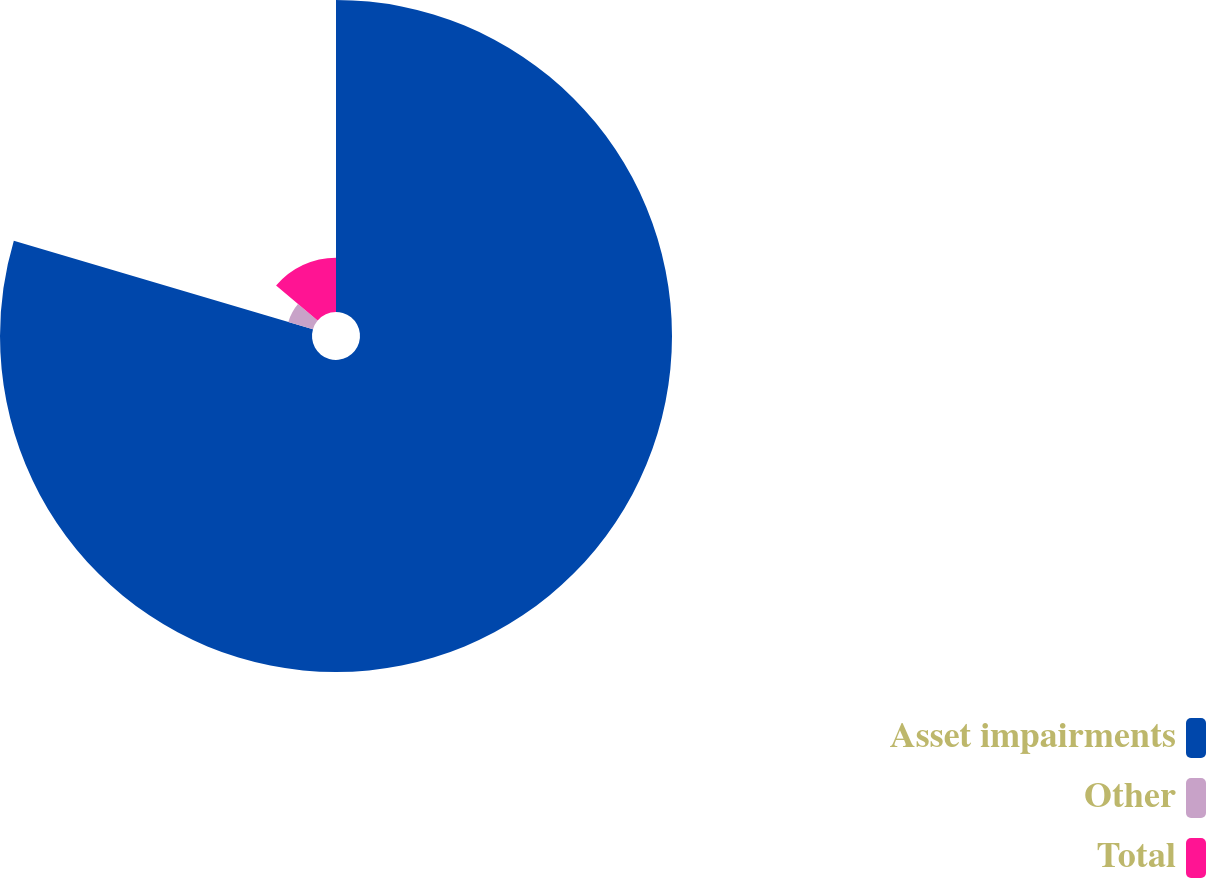<chart> <loc_0><loc_0><loc_500><loc_500><pie_chart><fcel>Asset impairments<fcel>Other<fcel>Total<nl><fcel>79.58%<fcel>6.56%<fcel>13.86%<nl></chart> 